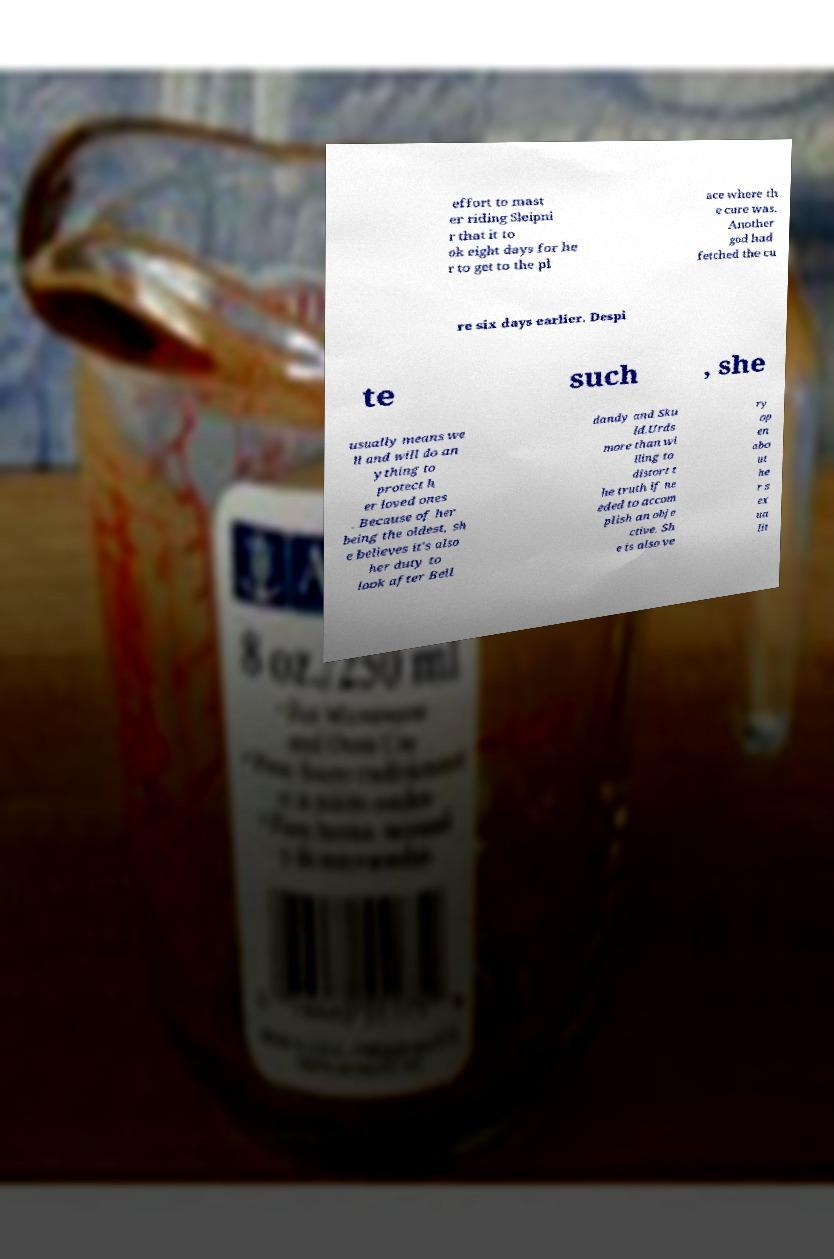Please read and relay the text visible in this image. What does it say? effort to mast er riding Sleipni r that it to ok eight days for he r to get to the pl ace where th e cure was. Another god had fetched the cu re six days earlier. Despi te such , she usually means we ll and will do an ything to protect h er loved ones . Because of her being the oldest, sh e believes it's also her duty to look after Bell dandy and Sku ld.Urds more than wi lling to distort t he truth if ne eded to accom plish an obje ctive. Sh e is also ve ry op en abo ut he r s ex ua lit 